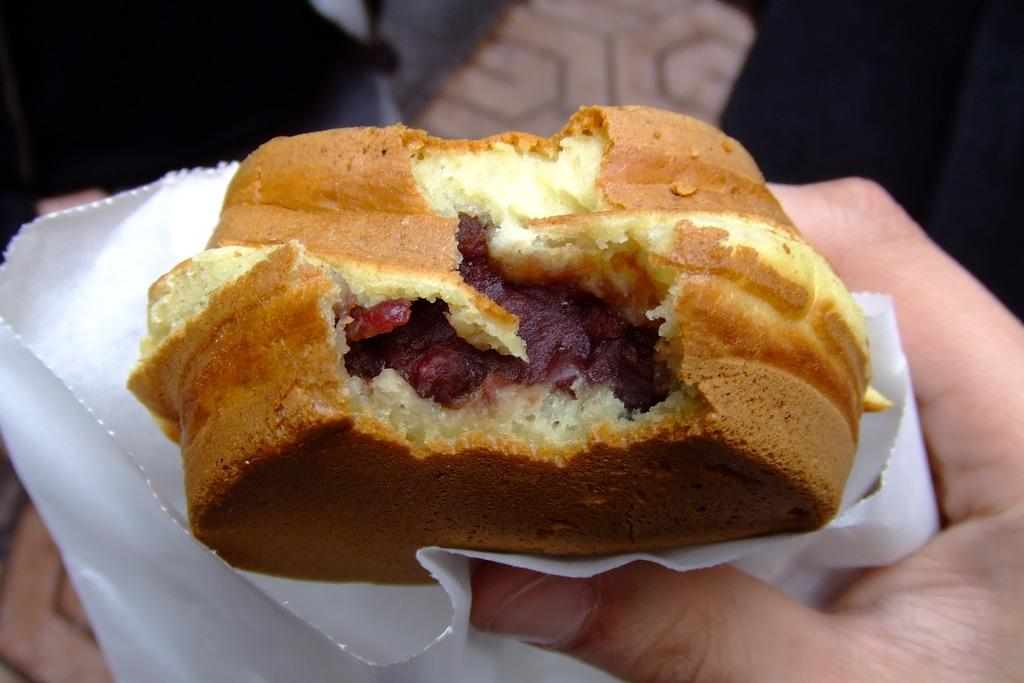What is the person's hand holding in the image? There is a person's hand holding a burger in the image. What might be used for cleaning or wiping in the image? There is a napkin in the image for cleaning or wiping. What is the condition of the person's hand while holding the burger in the image? The condition of the person's hand cannot be determined from the image alone. What operation is being performed on the burger in the image? There is no indication of an operation being performed on the burger in the image. 